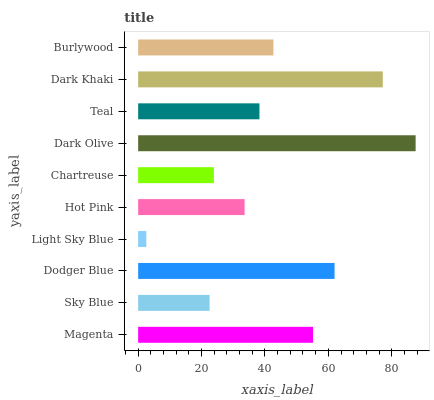Is Light Sky Blue the minimum?
Answer yes or no. Yes. Is Dark Olive the maximum?
Answer yes or no. Yes. Is Sky Blue the minimum?
Answer yes or no. No. Is Sky Blue the maximum?
Answer yes or no. No. Is Magenta greater than Sky Blue?
Answer yes or no. Yes. Is Sky Blue less than Magenta?
Answer yes or no. Yes. Is Sky Blue greater than Magenta?
Answer yes or no. No. Is Magenta less than Sky Blue?
Answer yes or no. No. Is Burlywood the high median?
Answer yes or no. Yes. Is Teal the low median?
Answer yes or no. Yes. Is Sky Blue the high median?
Answer yes or no. No. Is Chartreuse the low median?
Answer yes or no. No. 